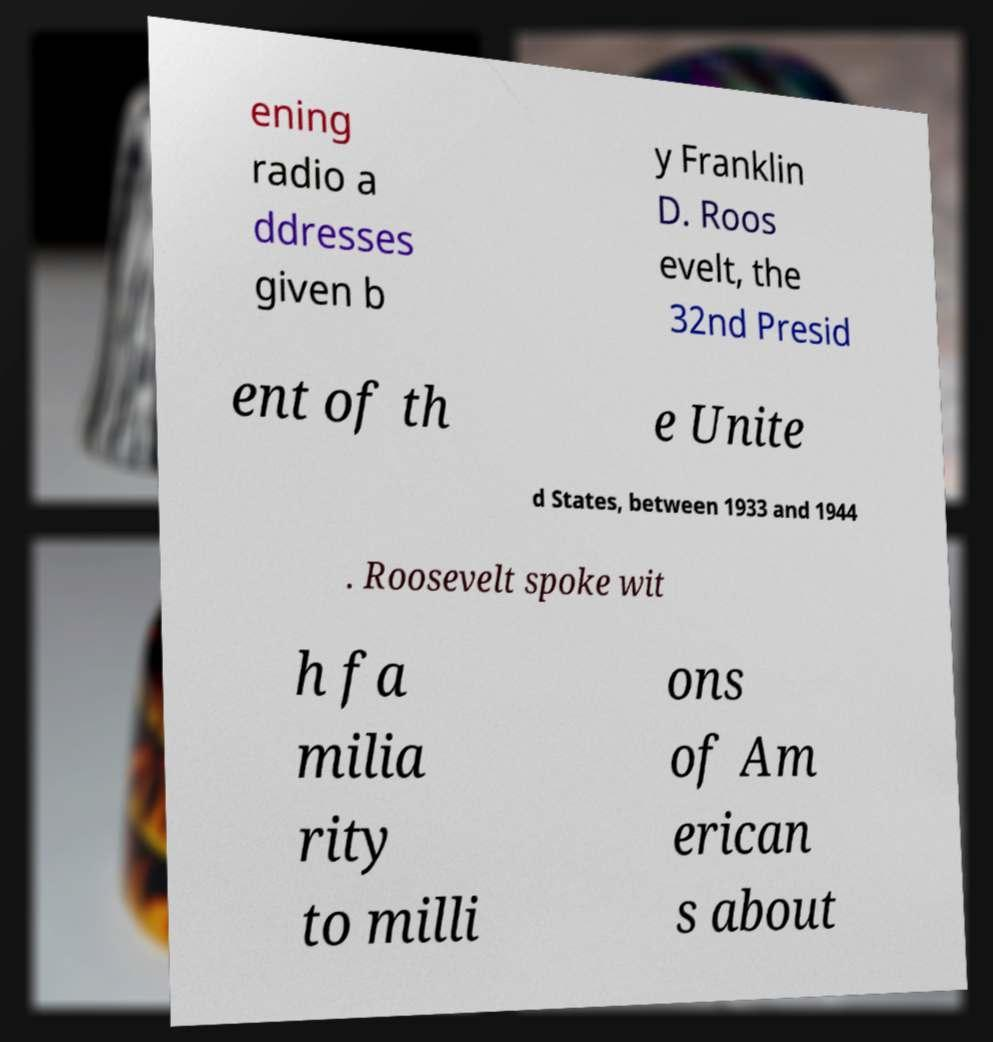Please identify and transcribe the text found in this image. ening radio a ddresses given b y Franklin D. Roos evelt, the 32nd Presid ent of th e Unite d States, between 1933 and 1944 . Roosevelt spoke wit h fa milia rity to milli ons of Am erican s about 